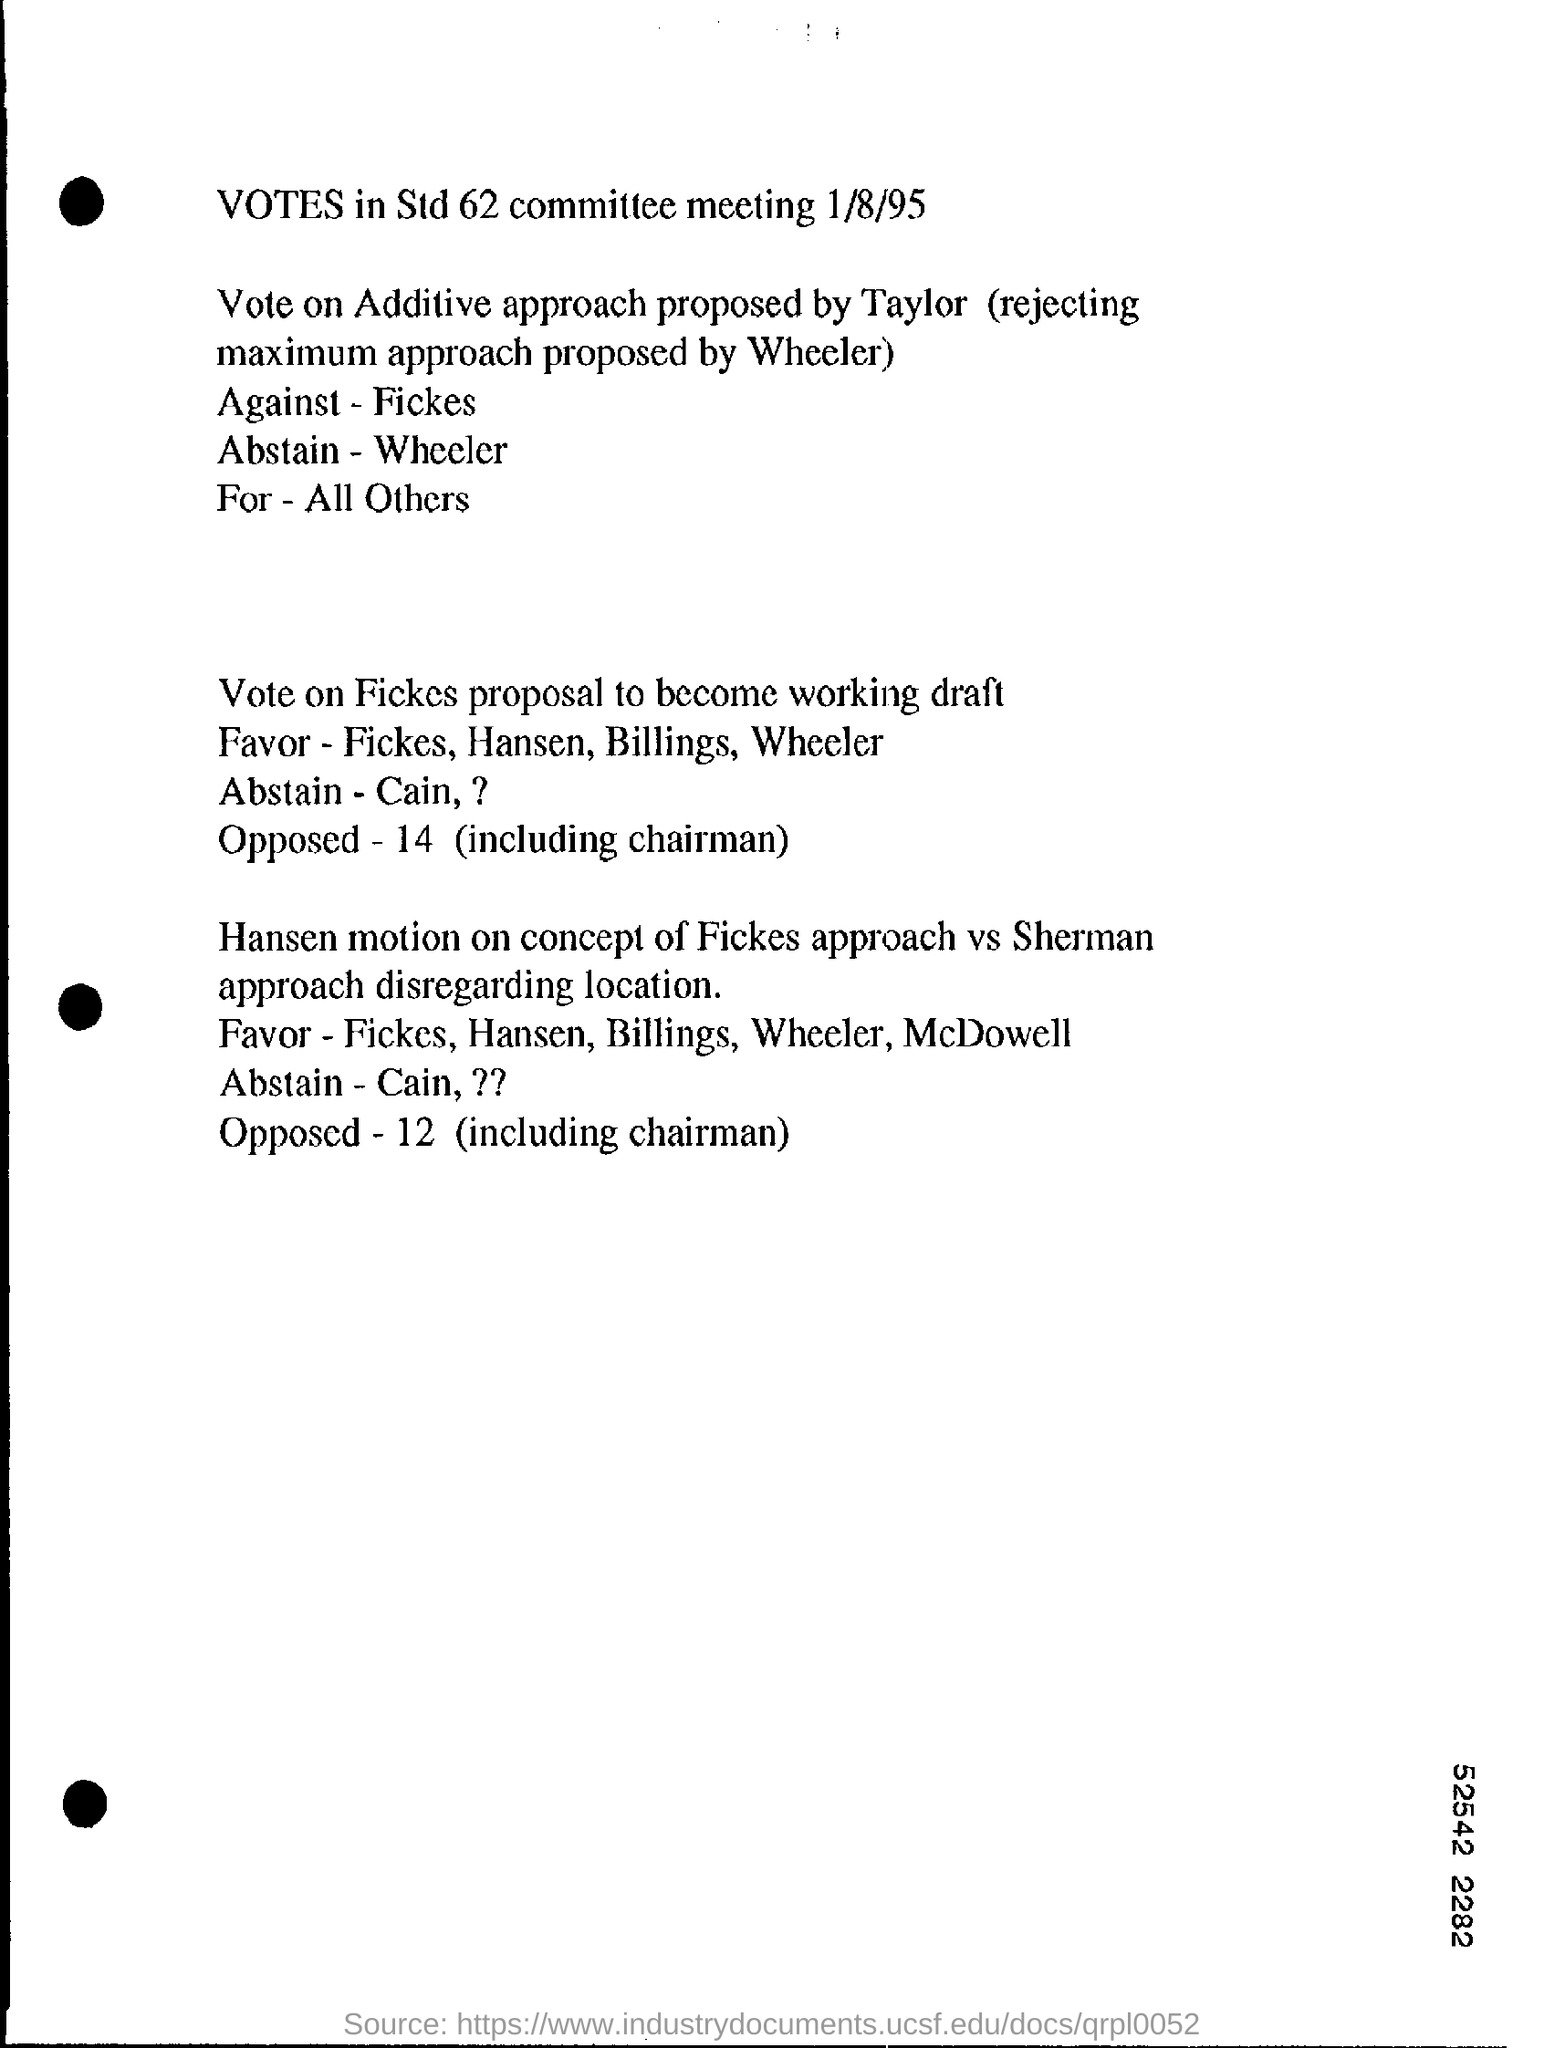Highlight a few significant elements in this photo. Who is voting against the proposed additive approach by Taylor and Fickes? According to the votes cast, 14 votes were opposed to the proposal to make it a working draft. 